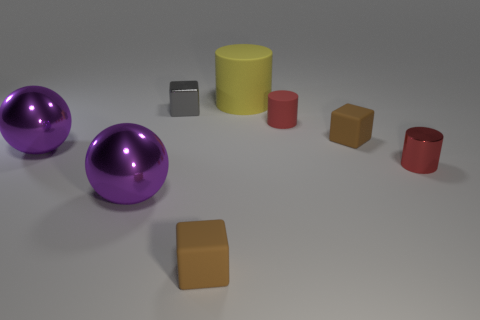Do the large yellow thing and the gray block have the same material?
Offer a terse response. No. How many things are on the left side of the yellow matte object?
Keep it short and to the point. 4. There is a thing that is both behind the tiny rubber cylinder and to the right of the gray cube; what is it made of?
Your response must be concise. Rubber. What number of purple metallic balls have the same size as the yellow rubber cylinder?
Offer a terse response. 2. What is the color of the tiny matte thing to the left of the big matte cylinder behind the small red metal object?
Your response must be concise. Brown. Are any tiny shiny cylinders visible?
Your answer should be very brief. Yes. Do the yellow object and the small gray metallic thing have the same shape?
Offer a terse response. No. The thing that is the same color as the metallic cylinder is what size?
Provide a succinct answer. Small. There is a tiny brown cube that is to the left of the yellow object; how many metallic cylinders are left of it?
Ensure brevity in your answer.  0. What number of metallic things are on the right side of the red rubber object and on the left side of the small gray thing?
Give a very brief answer. 0. 